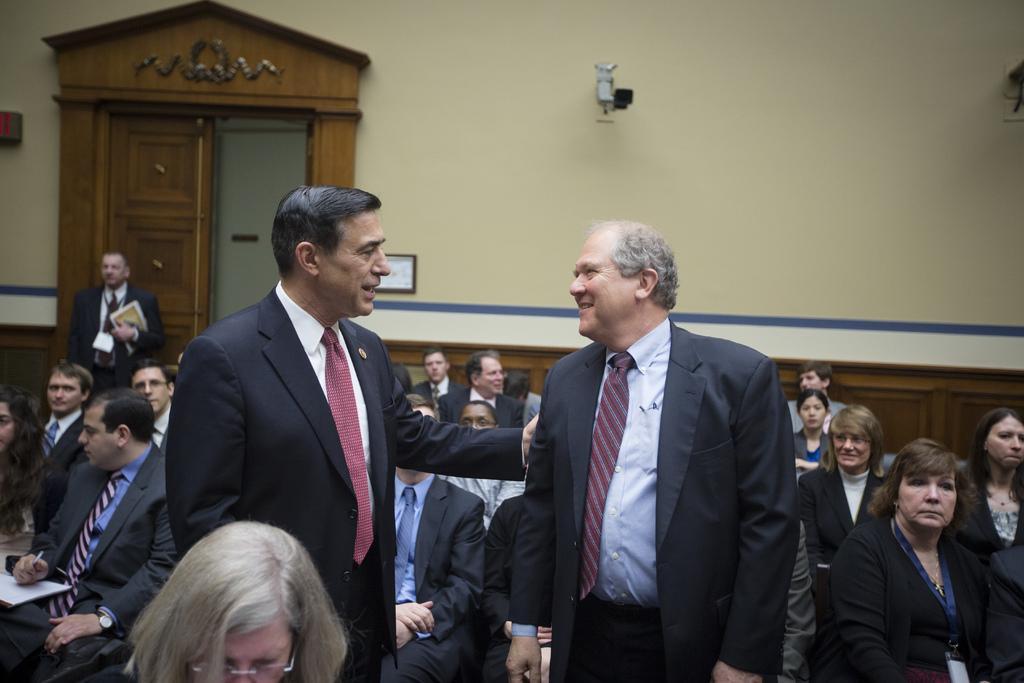Describe this image in one or two sentences. In this image I can see a group of people are sitting on the chairs and three persons are standing on the floor. In the background I can see a wall, door and a photo frame. This image is taken may be in a hall. 